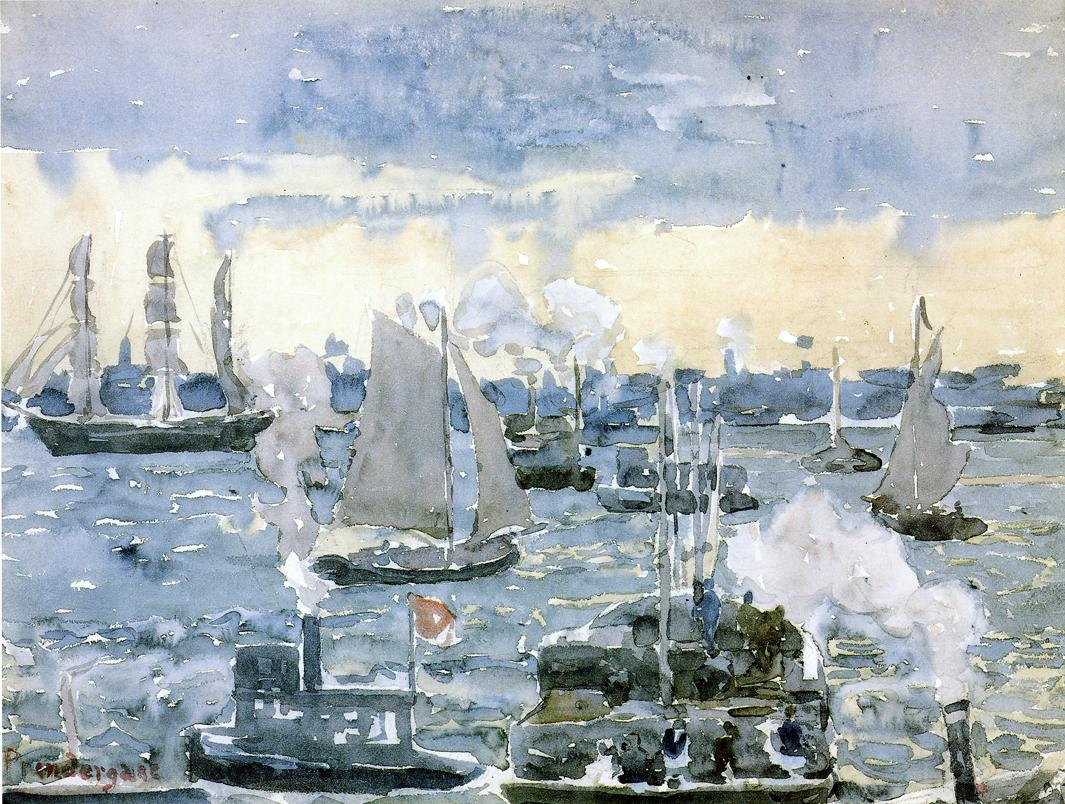Can you describe the mood of this painting? The mood of this painting is serene yet bustling, capturing the essence of an industrious harbor on a cloudy day. The fluid brushstrokes and muted color palette evoke a sense of calm and tranquility, while the presence of various boats and ships, along with the choppy waters, infuse the scene with a subtle energy and movement. How does the artist create this sense of movement and energy? The artist creates a sense of movement and energy through several techniques. The use of quick, broad brushstrokes and a loose painting style captures the dynamic motion of the water and the bustling activity of the harbor. The contrast between the billowing sails of the boats and the steady presence of the steamships' smokestacks illustrates the juxtaposition of nature and industry in motion. Additionally, the reflection of the choppy water and the cloudy sky further enhances the vibrant and lively atmosphere of the scene. Imagine you could step into this painting. Describe what you would experience using all your senses. Stepping into this painting, you are immediately enveloped by the soft yet fresh scent of the sea breeze, mixed with the faint smell of coal from the steamships. The cool, salty air brushes against your skin as your feet lightly tap against the wet, wooden docks. The harbor is alive with sounds: the gentle lapping of waves against the boats, the distant chatter of seagulls, and occasional clanging of metal as ships prepare to dock. You feel the vibrant energy of the scene, surrounded by boats of varying sizes, their sails fluttering in the wind. The cloudy sky above shifts subtly, changing the light and casting a reflective shimmer on the water. This bustling harbor is filled with both movement and stillness, a juxtaposition that makes the scene feel both lively and peaceful. 